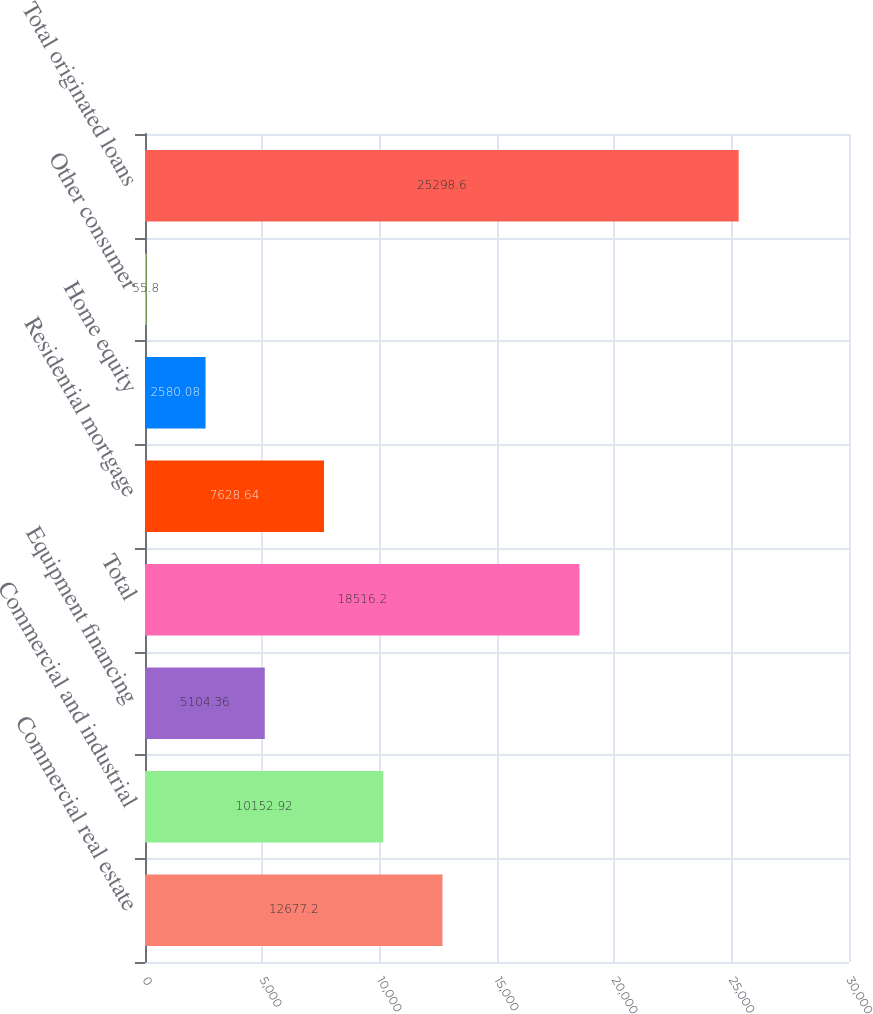<chart> <loc_0><loc_0><loc_500><loc_500><bar_chart><fcel>Commercial real estate<fcel>Commercial and industrial<fcel>Equipment financing<fcel>Total<fcel>Residential mortgage<fcel>Home equity<fcel>Other consumer<fcel>Total originated loans<nl><fcel>12677.2<fcel>10152.9<fcel>5104.36<fcel>18516.2<fcel>7628.64<fcel>2580.08<fcel>55.8<fcel>25298.6<nl></chart> 